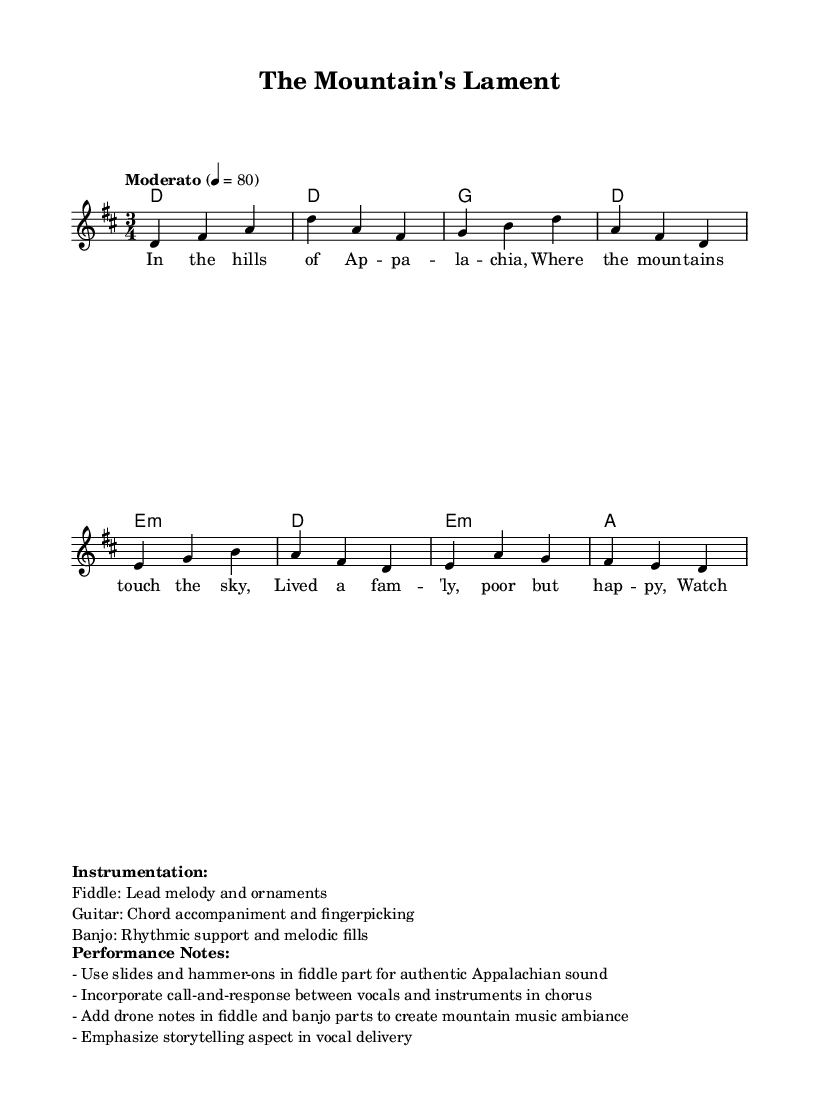What is the key signature of this music? The key signature is indicated at the beginning of the staff and shows two sharps, which corresponds to D major.
Answer: D major What is the time signature of this music? The time signature is shown at the beginning of the piece and is written as 3/4, indicating three beats per measure.
Answer: 3/4 What is the tempo marking for this piece? The tempo marking is found at the start of the score, indicating "Moderato" with a speed of 80 beats per minute, which indicates a moderate pace.
Answer: Moderato How many measures are there in the melody? By counting the distinct segments in the melody section, we can find that there are eight measures present.
Answer: Eight What instruments are specified for this piece? The instruments are listed in the markup sections below the score, which prominently mentions the fiddle, guitar, and banjo for their respective roles.
Answer: Fiddle, Guitar, Banjo What is the main theme depicted in the lyrics of this ballad? The lyrics reflect the experiences of a happy family living in the Appalachian mountains, emphasizing the simplicity and beauty of rural life, and watching the seasons change.
Answer: Rural life What performance techniques are recommended for authenticity? The performance notes recommend using slides and hammer-ons in the fiddle part and incorporating call-and-response between vocals and instruments for an authentic Appalachian sound.
Answer: Slides, Hammer-ons, Call-and-response 